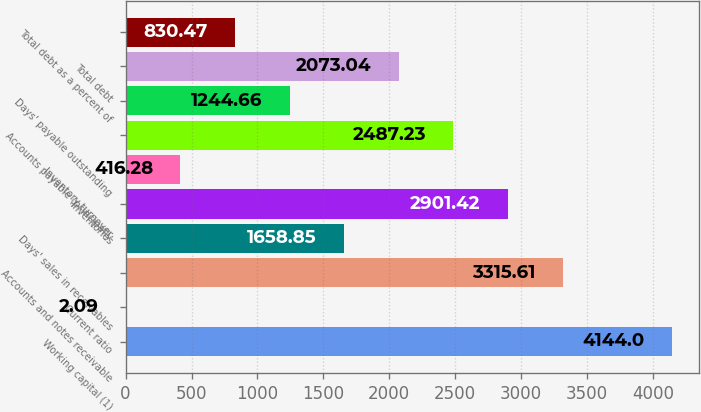<chart> <loc_0><loc_0><loc_500><loc_500><bar_chart><fcel>Working capital (1)<fcel>Current ratio<fcel>Accounts and notes receivable<fcel>Days' sales in receivables<fcel>Inventories<fcel>Inventory turnover<fcel>Accounts payable (principally<fcel>Days' payable outstanding<fcel>Total debt<fcel>Total debt as a percent of<nl><fcel>4144<fcel>2.09<fcel>3315.61<fcel>1658.85<fcel>2901.42<fcel>416.28<fcel>2487.23<fcel>1244.66<fcel>2073.04<fcel>830.47<nl></chart> 